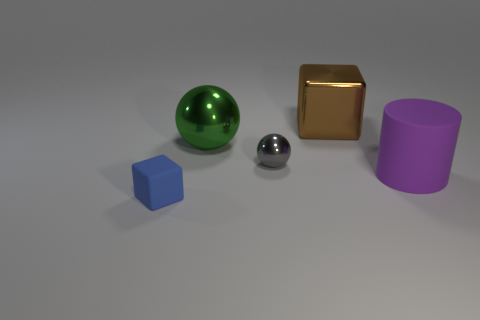Which shapes in the image would fit within each other? Assuming the objects can be resized while keeping their proportions, the small silver sphere could fit within any of the other shapes due to its size and round form. None of the other objects seem to have dimensions that would allow them to fit within each other without modification. 